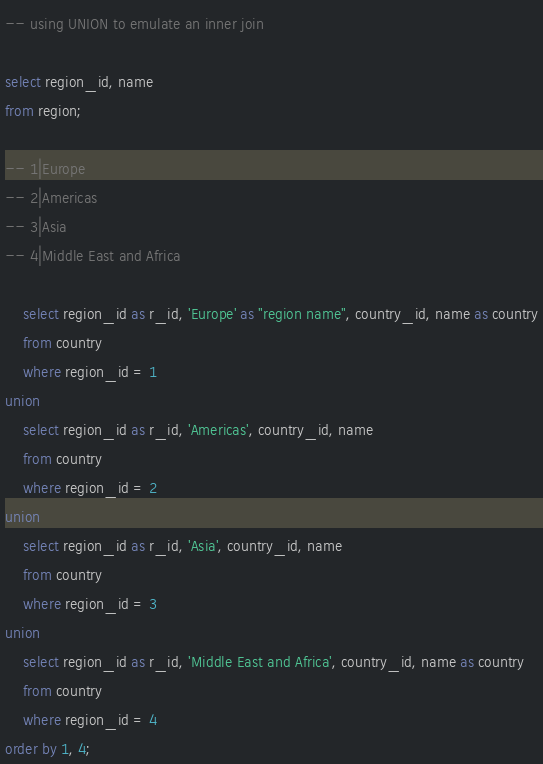<code> <loc_0><loc_0><loc_500><loc_500><_SQL_>-- using UNION to emulate an inner join

select region_id, name
from region;

-- 1|Europe
-- 2|Americas
-- 3|Asia
-- 4|Middle East and Africa

	select region_id as r_id, 'Europe' as "region name", country_id, name as country
	from country
	where region_id = 1
union
	select region_id as r_id, 'Americas', country_id, name
	from country
	where region_id = 2
union
	select region_id as r_id, 'Asia', country_id, name
	from country
	where region_id = 3
union
	select region_id as r_id, 'Middle East and Africa', country_id, name as country
	from country
	where region_id = 4
order by 1, 4;
</code> 